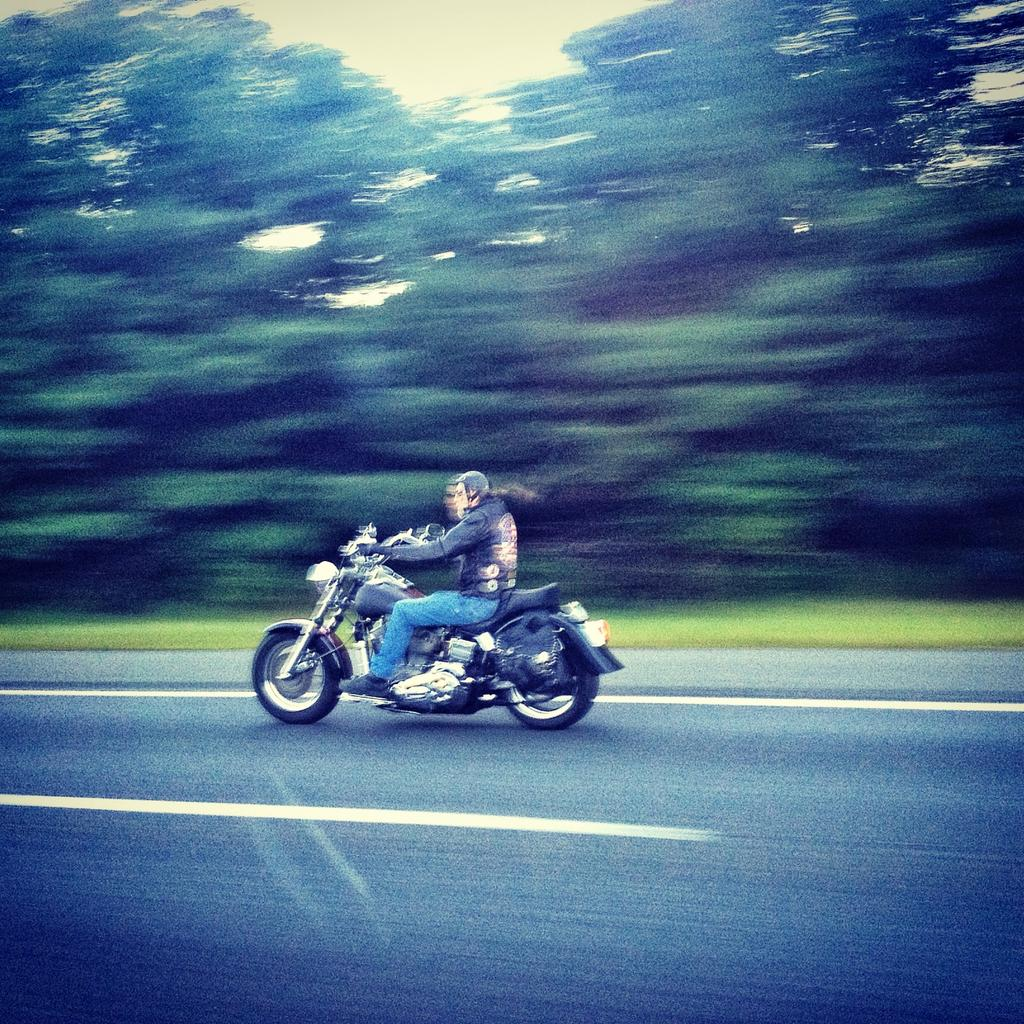What type of vegetation can be seen in the image? There are trees in the image. What type of transportation infrastructure is present in the image? There is a road in the image. What mode of transportation is the man using in the image? The man is on a motorcycle in the image. What type of sign can be seen warning about a potential burn hazard in the image? There is no sign present in the image, nor is there any indication of a burn hazard. 